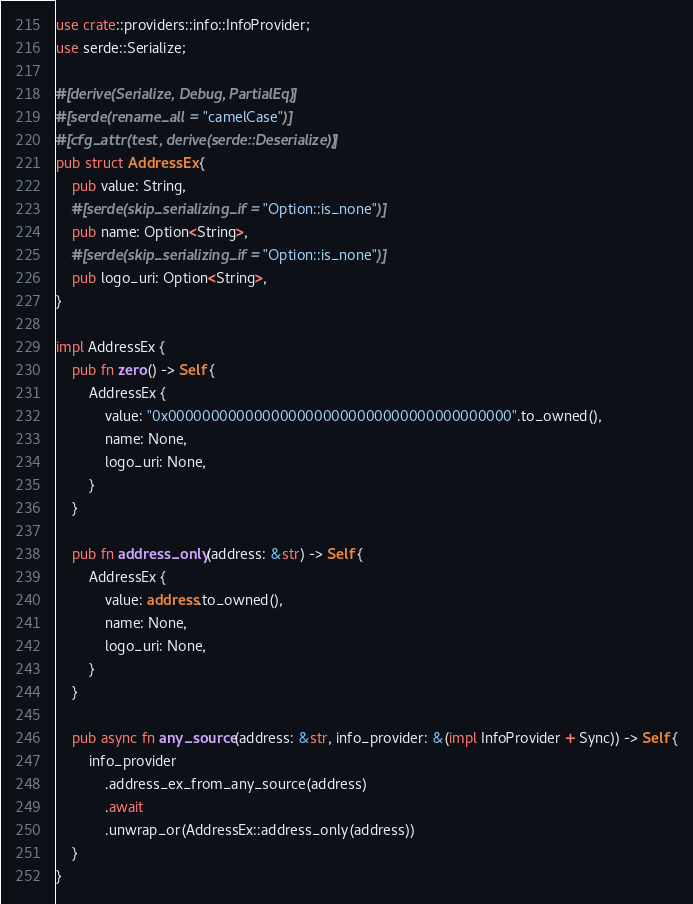Convert code to text. <code><loc_0><loc_0><loc_500><loc_500><_Rust_>use crate::providers::info::InfoProvider;
use serde::Serialize;

#[derive(Serialize, Debug, PartialEq)]
#[serde(rename_all = "camelCase")]
#[cfg_attr(test, derive(serde::Deserialize))]
pub struct AddressEx {
    pub value: String,
    #[serde(skip_serializing_if = "Option::is_none")]
    pub name: Option<String>,
    #[serde(skip_serializing_if = "Option::is_none")]
    pub logo_uri: Option<String>,
}

impl AddressEx {
    pub fn zero() -> Self {
        AddressEx {
            value: "0x0000000000000000000000000000000000000000".to_owned(),
            name: None,
            logo_uri: None,
        }
    }

    pub fn address_only(address: &str) -> Self {
        AddressEx {
            value: address.to_owned(),
            name: None,
            logo_uri: None,
        }
    }

    pub async fn any_source(address: &str, info_provider: &(impl InfoProvider + Sync)) -> Self {
        info_provider
            .address_ex_from_any_source(address)
            .await
            .unwrap_or(AddressEx::address_only(address))
    }
}
</code> 